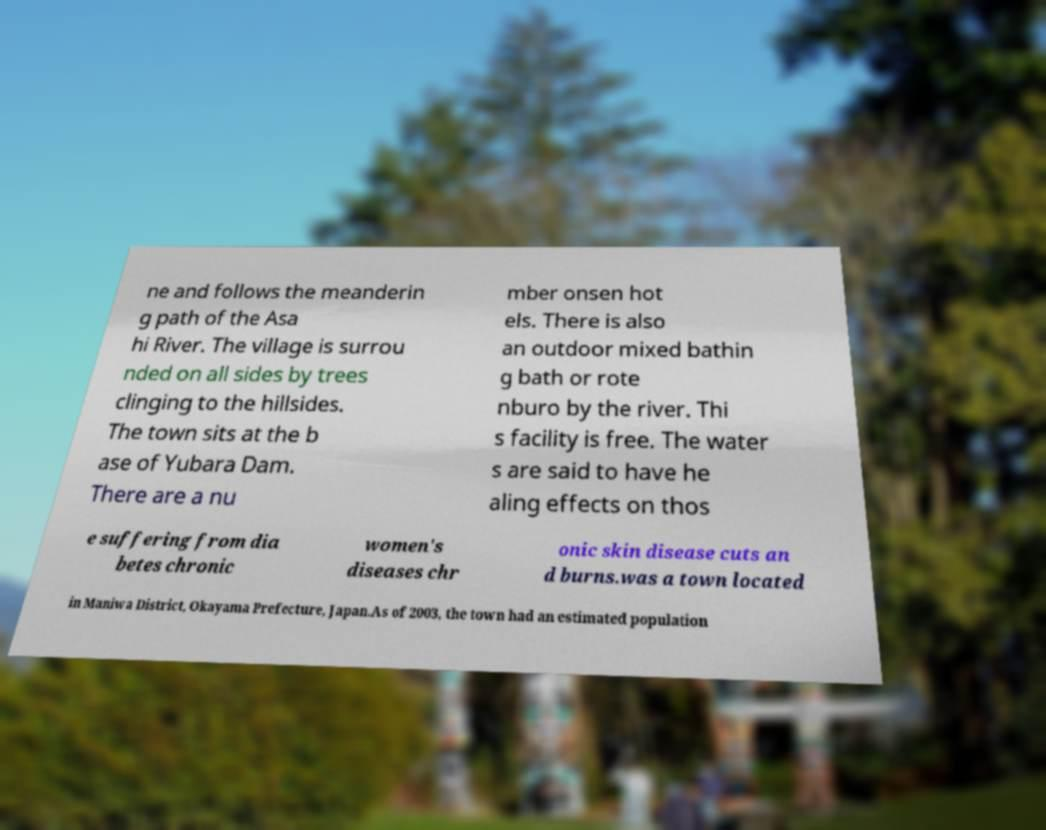I need the written content from this picture converted into text. Can you do that? ne and follows the meanderin g path of the Asa hi River. The village is surrou nded on all sides by trees clinging to the hillsides. The town sits at the b ase of Yubara Dam. There are a nu mber onsen hot els. There is also an outdoor mixed bathin g bath or rote nburo by the river. Thi s facility is free. The water s are said to have he aling effects on thos e suffering from dia betes chronic women's diseases chr onic skin disease cuts an d burns.was a town located in Maniwa District, Okayama Prefecture, Japan.As of 2003, the town had an estimated population 